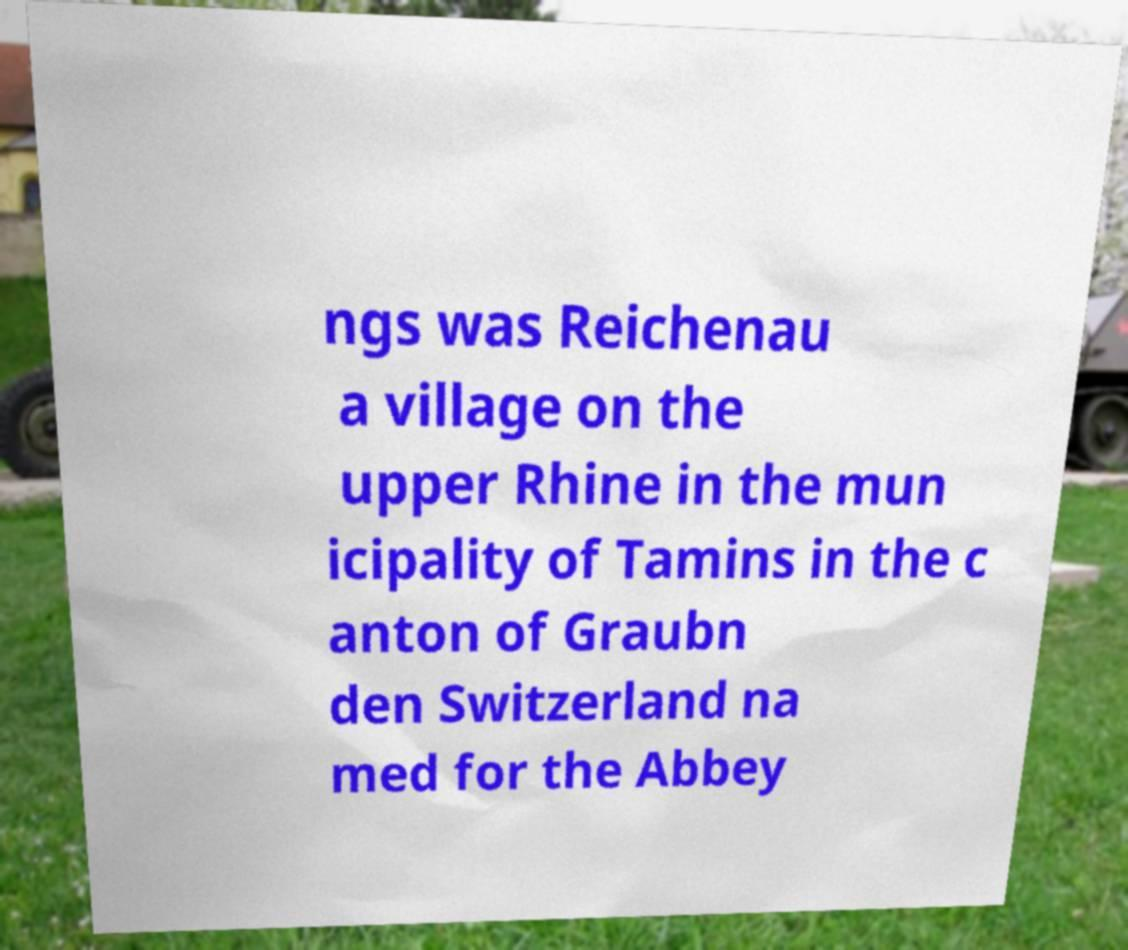What messages or text are displayed in this image? I need them in a readable, typed format. ngs was Reichenau a village on the upper Rhine in the mun icipality of Tamins in the c anton of Graubn den Switzerland na med for the Abbey 